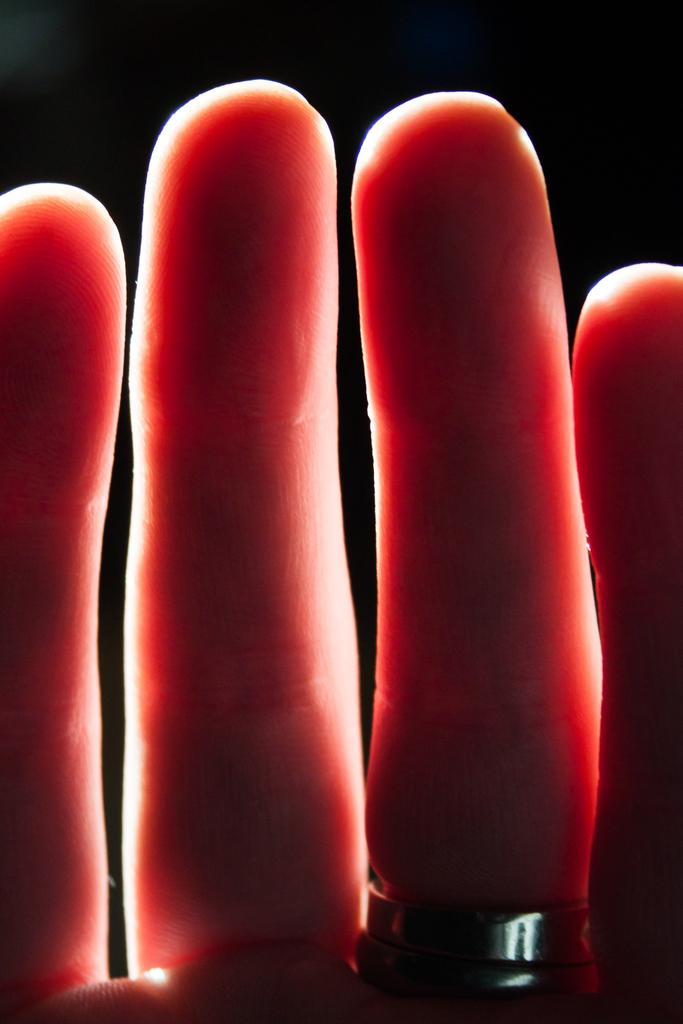What body parts are visible in the image? There are fingers visible in the image. What type of jewelry can be seen on the fingers? There are rings visible in the image. What is the color of the background in the image? The background of the image is dark. Can you see a goat grazing on clover in the image? There is no goat or clover present in the image. Who is the servant attending to in the image? There is no servant or person being attended to in the image. 